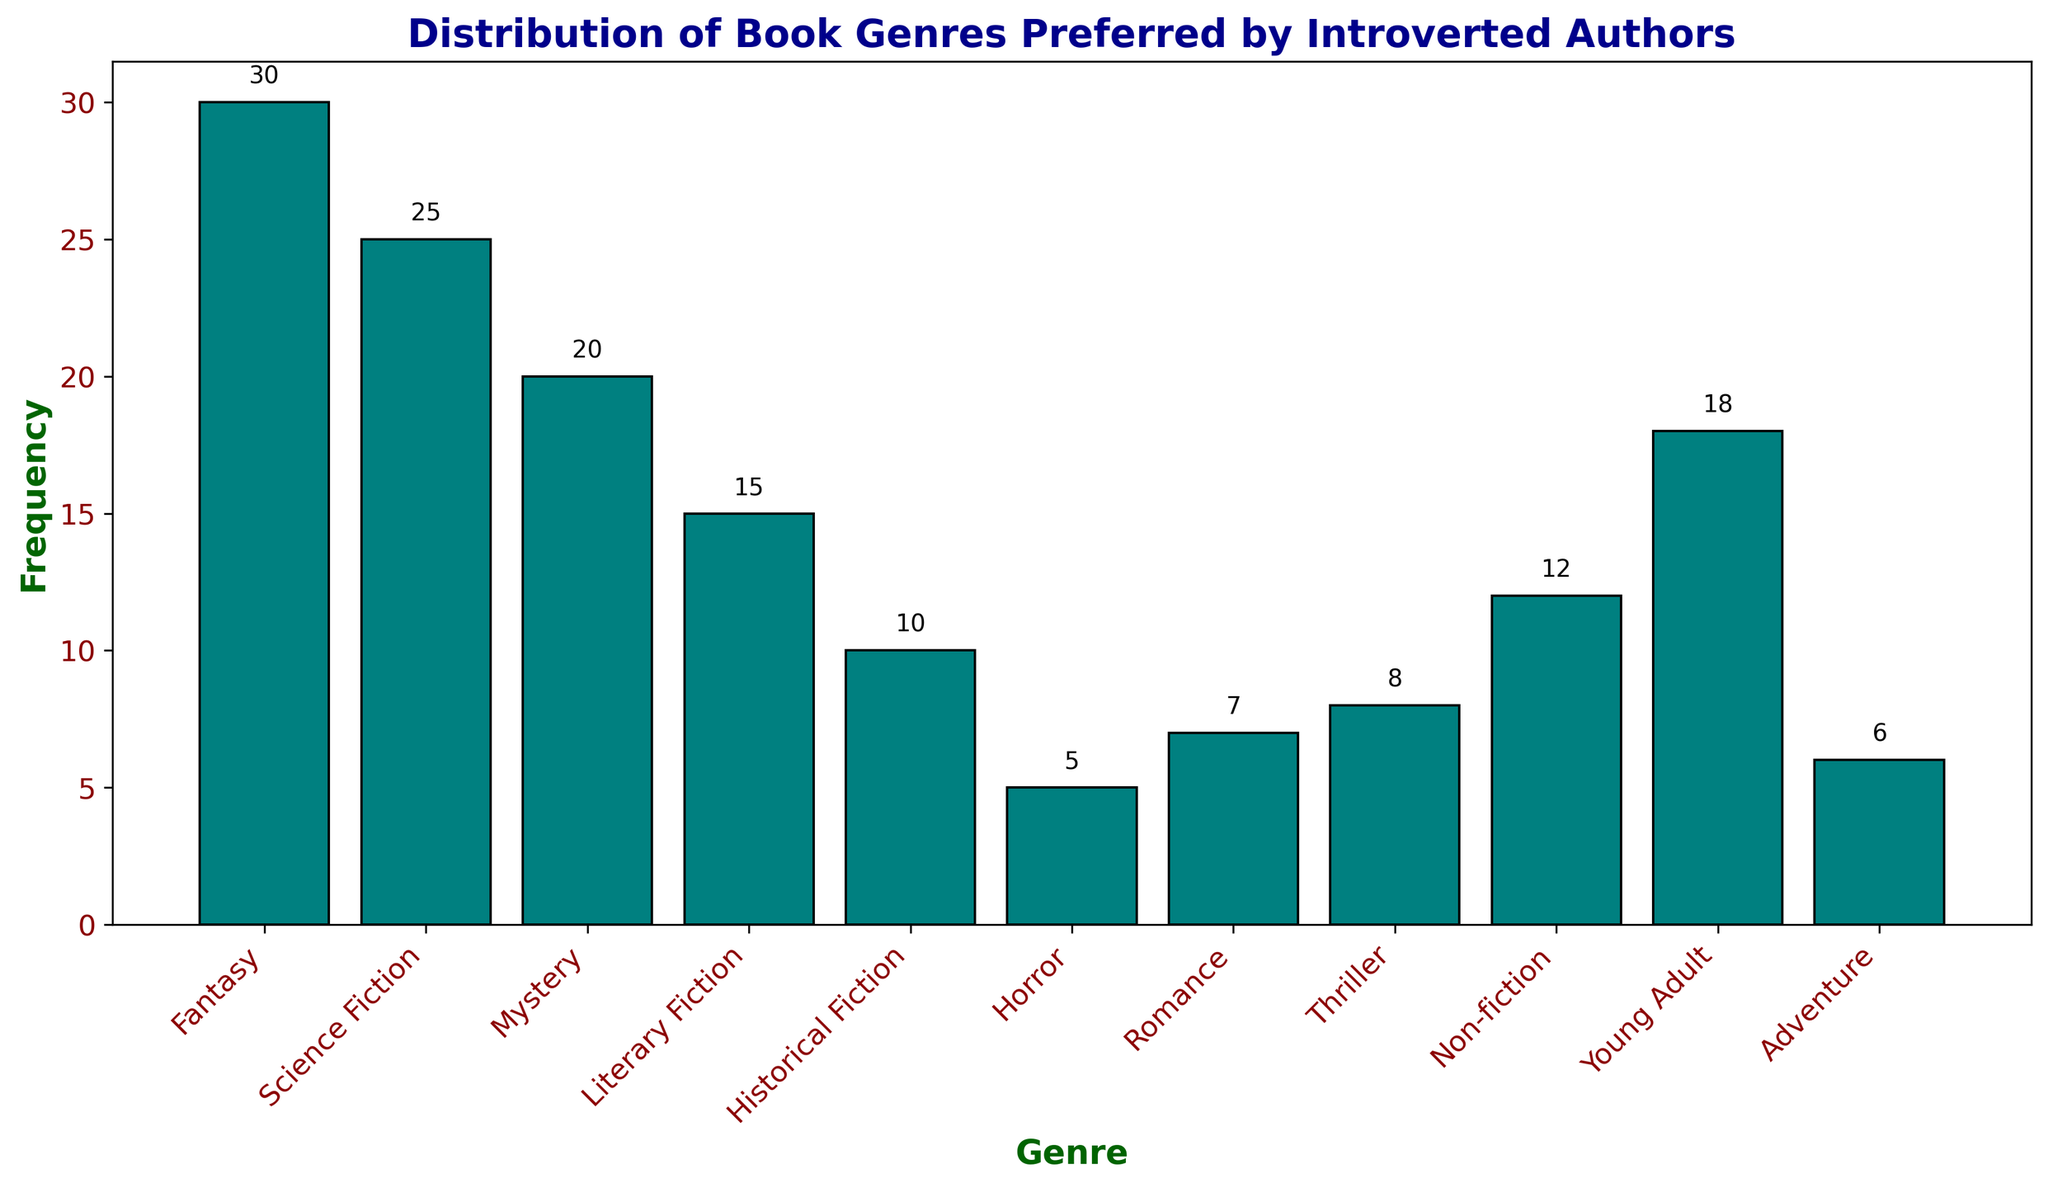Which genre is the most preferred by introverted authors? To determine the most preferred genre, look for the bar with the greatest height. The tallest bar represents Fantasy with a height of 30, indicating it is the most preferred genre.
Answer: Fantasy Which genre is the least preferred by introverted authors? To find the least preferred genre, identify the bar with the smallest height. The smallest bar represents Horror with a height of 5, indicating it is the least preferred.
Answer: Horror How many genres have a frequency of more than 15? Count the number of bars that have a height greater than 15. The bars representing Fantasy (30), Science Fiction (25), and Mystery (20) meet this criterion, totaling 3 genres.
Answer: 3 Which genre has a frequency closest to 10? Identify the bar with a height closest to 10. Historical Fiction has a frequency of 10, which is exactly 10 and thus the closest.
Answer: Historical Fiction What is the total frequency of genres preferred by introverted authors? Sum the heights of all bars. The frequencies are 30, 25, 20, 15, 10, 5, 7, 8, 12, 18, and 6. The total frequency is 30 + 25 + 20 + 15 + 10 + 5 + 7 + 8 + 12 + 18 + 6 = 156.
Answer: 156 How many more authors prefer Fantasy over Non-fiction? Subtract the height of the Non-fiction bar from the Fantasy bar. Fantasy has a height of 30 and Non-fiction has a height of 12. So, 30 - 12 = 18.
Answer: 18 Which genres have frequencies between 5 and 12 inclusive? Identify bars with heights between 5 and 12. The bars representing Non-fiction (12), Thriller (8), Romance (7), Adventure (6), and Horror (5) fit this range.
Answer: Non-fiction, Thriller, Romance, Adventure, Horror What is the difference in frequency between the third most and least preferred genres? Identify the frequencies for the third most preferred (Mystery, 20) and the least preferred (Horror, 5) genres and subtract them. So, 20 - 5 = 15.
Answer: 15 What is the average frequency of all the genres preferred by introverted authors? Calculate the mean frequency by summing the heights of all bars and dividing by their count. Total frequency is 156, number of genres is 11. The average is 156 ÷ 11 ≈ 14.18.
Answer: 14.18 